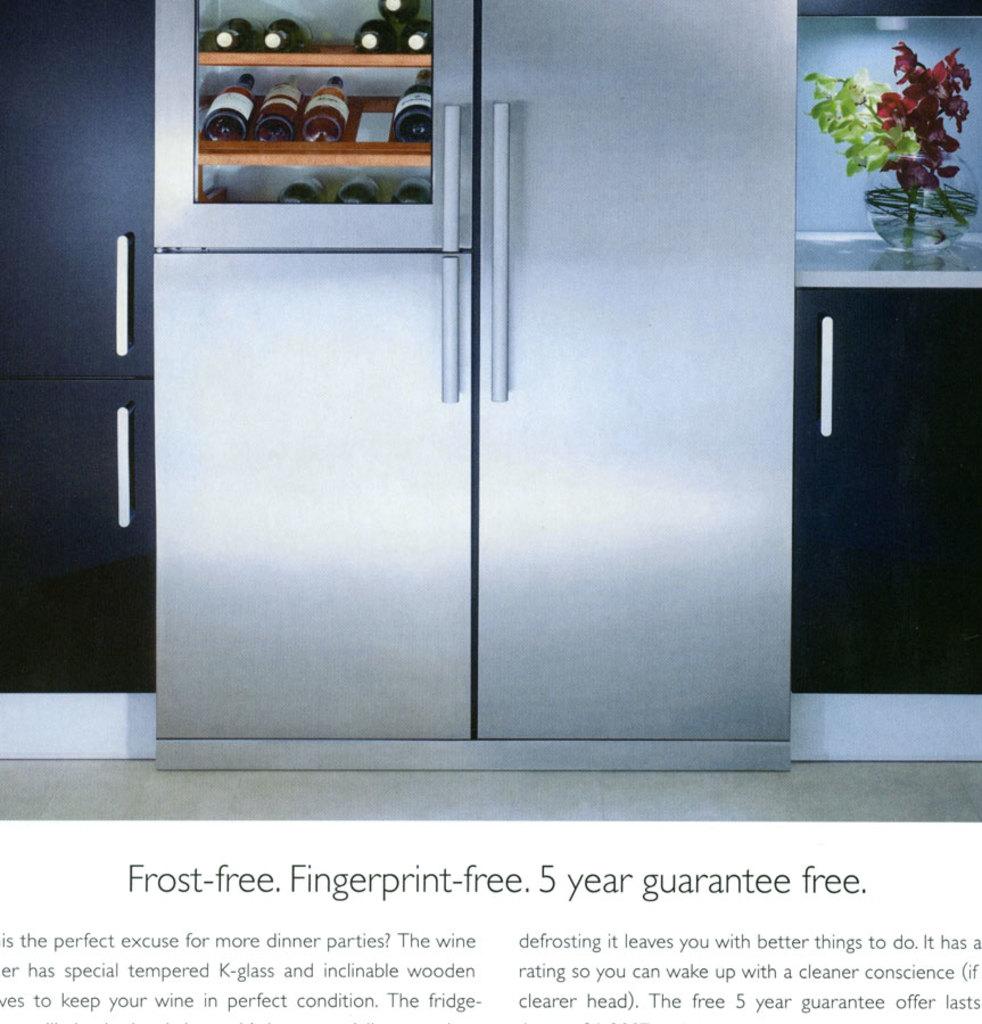How many years is it guarantee free?
Provide a short and direct response. 5. How long is the guarantee on this refrigerator?
Your answer should be compact. 5 years. 